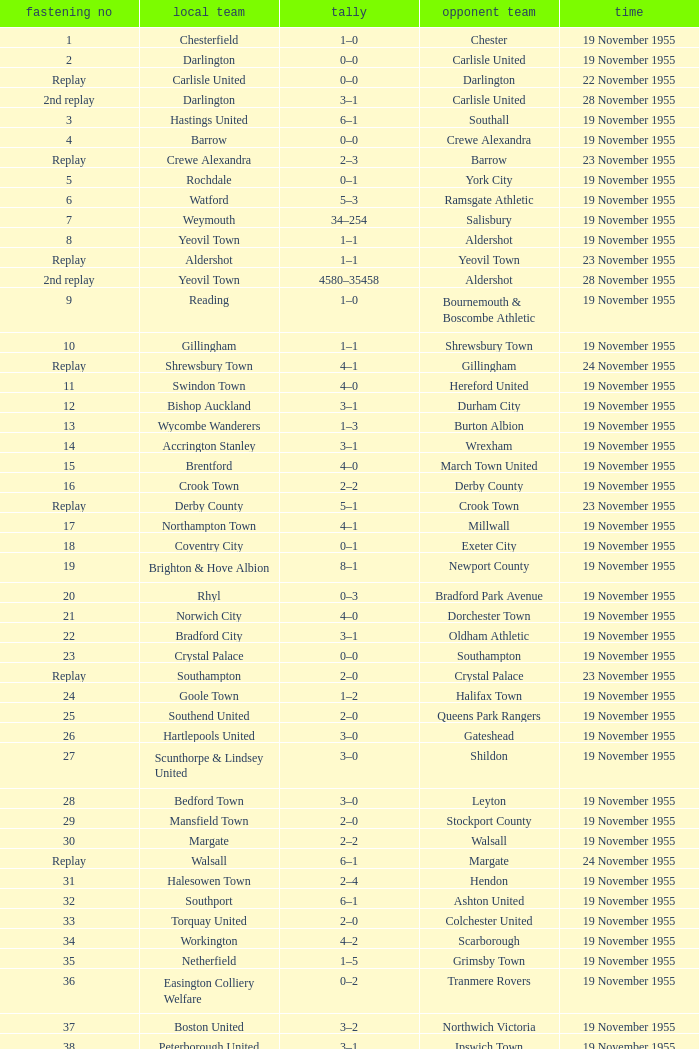What is the date of tie no. 34? 19 November 1955. 